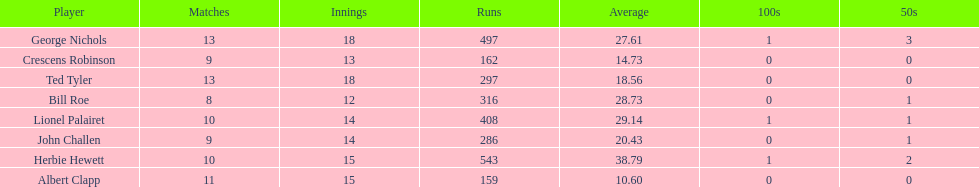Which player had the least amount of runs? Albert Clapp. 